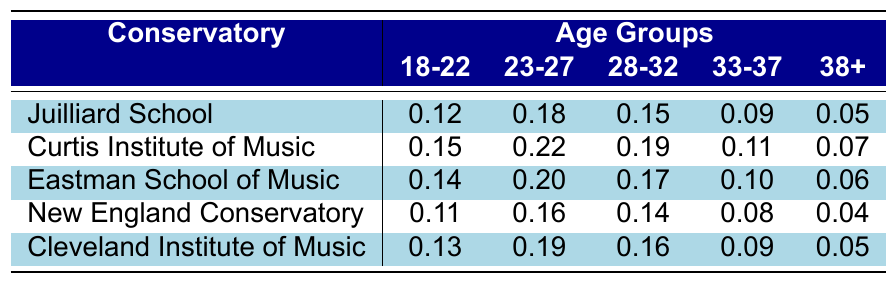What is the audition success rate for clarinetists aged 23-27 at the Curtis Institute of Music? The table shows the relevant data for the Curtis Institute of Music under the age group 23-27, which is 0.22.
Answer: 0.22 Which conservatory has the highest audition success rate for the age group 18-22? By examining the values for age group 18-22 across all conservatories, the highest value is 0.15 at the Curtis Institute of Music.
Answer: Curtis Institute of Music What is the lowest audition success rate in the table for clarinetists aged 38 and above? The table shows the audition success rates for the age group 38+; the lowest value is 0.04 from the New England Conservatory.
Answer: 0.04 Calculate the average audition success rate for clarinetists aged 28-32 across all conservatories. The values for the age group 28-32 are 0.15, 0.19, 0.17, 0.14, and 0.16. Summing them gives 0.15 + 0.19 + 0.17 + 0.14 + 0.16 = 0.81. The average is 0.81 divided by 5, which equals 0.162.
Answer: 0.162 Is the audition success rate for clarinetists aged 33-37 higher at the Eastman School of Music than at the New England Conservatory? The Eastman School of Music has a rate of 0.10 for the age group 33-37, while the New England Conservatory has a rate of 0.08. Since 0.10 is greater than 0.08, the statement is true.
Answer: Yes What is the difference in audition success rates between the Juilliard School and the Cleveland Institute of Music for the age group 23-27? The audition success rate for Juilliard School in this age group is 0.18, and for the Cleveland Institute of Music, it is 0.19. The difference is 0.19 - 0.18 = 0.01.
Answer: 0.01 Which conservatory has the lowest audition success rate for clarinetists aged 33-37? Looking at the values for the 33-37 age group, New England Conservatory has the lowest rate of 0.08 compared to the other conservatories.
Answer: New England Conservatory What is the total audition success rate for the age group 18-22 across all conservatories? Summing the audition success rates for the age group 18-22 gives: 0.12 + 0.15 + 0.14 + 0.11 + 0.13 = 0.65.
Answer: 0.65 Has the Curtis Institute of Music consistently higher audition success rates than the Cleveland Institute of Music across all age groups? Comparing their rates shows that for age groups 18-22, 23-27, and 28-32, Curtis has higher rates (0.15 > 0.13, 0.22 > 0.19, 0.19 > 0.16), but for 33-37, Cleveland (0.09) is higher than Curtis (0.11), and for 38+, they are equal. So, the statement is false.
Answer: No What age group shows the most significant decrease in audition success rates at the New England Conservatory? The age groups' success rates at New England Conservatory are 0.11 (18-22), 0.16 (23-27), 0.14 (28-32), 0.08 (33-37), and 0.04 (38+). The greatest decrease is from 0.08 to 0.04 between the 33-37 and 38+ age groups, which is a decrease of 0.04.
Answer: 33-37 to 38+ 